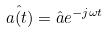<formula> <loc_0><loc_0><loc_500><loc_500>\hat { a ( t ) } = \hat { a } e ^ { - j \omega t }</formula> 